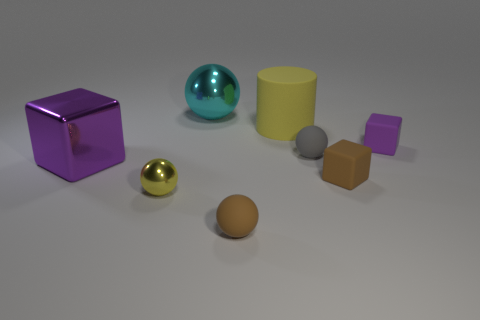Are there more tiny brown matte spheres that are behind the tiny metal thing than purple metallic objects? After carefully examining the image, the answer is no. There is only one tiny brown matte sphere located behind the small metallic sphere, whereas there are two purple metallic objects in the image, making the purple metallic objects more numerous. 